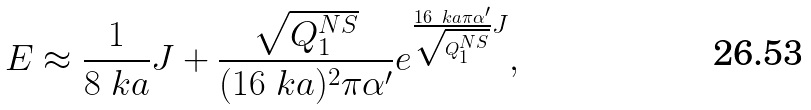Convert formula to latex. <formula><loc_0><loc_0><loc_500><loc_500>E \approx \frac { 1 } { 8 \ k a } J + \frac { \sqrt { Q _ { 1 } ^ { N S } } } { ( 1 6 \ k a ) ^ { 2 } \pi \alpha ^ { \prime } } e ^ { \frac { 1 6 \ k a \pi \alpha ^ { \prime } } { \sqrt { Q _ { 1 } ^ { N S } } } J } ,</formula> 